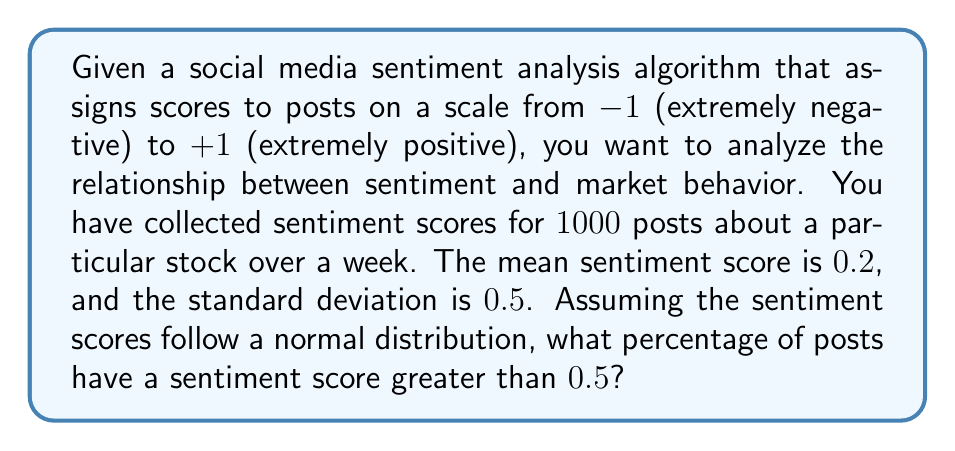Provide a solution to this math problem. To solve this problem, we need to use the properties of the normal distribution and the concept of z-scores. Here's a step-by-step approach:

1. Identify the given information:
   - Mean sentiment score (μ) = 0.2
   - Standard deviation (σ) = 0.5
   - We want to find the percentage of scores greater than 0.5

2. Calculate the z-score for the sentiment score of 0.5:
   $$ z = \frac{x - \mu}{\sigma} $$
   where x is the score we're interested in (0.5)

   $$ z = \frac{0.5 - 0.2}{0.5} = \frac{0.3}{0.5} = 0.6 $$

3. Use a standard normal distribution table or calculator to find the area to the left of z = 0.6. This gives us the probability of a score being less than or equal to 0.5.

   P(Z ≤ 0.6) ≈ 0.7257

4. Since we want the probability of scores greater than 0.5, we subtract this value from 1:

   P(Z > 0.6) = 1 - P(Z ≤ 0.6) = 1 - 0.7257 = 0.2743

5. Convert the probability to a percentage:
   0.2743 * 100 = 27.43%

This result suggests that approximately 27.43% of the posts have a sentiment score greater than 0.5, indicating a moderately positive sentiment towards the stock.
Answer: 27.43% 